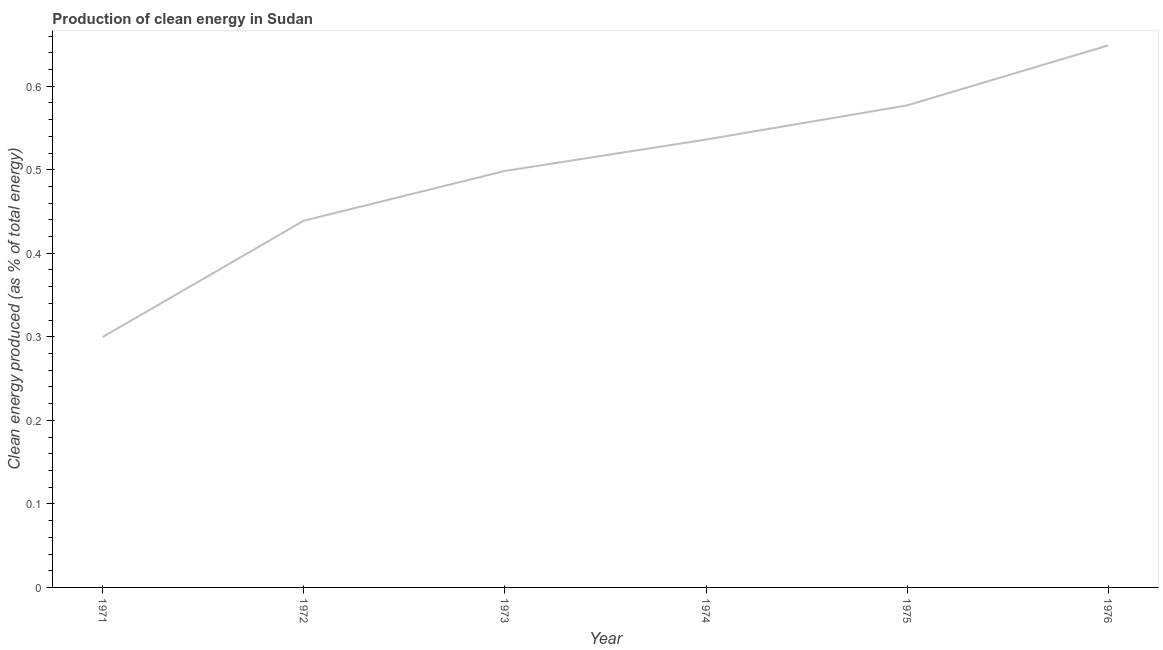What is the production of clean energy in 1971?
Ensure brevity in your answer.  0.3. Across all years, what is the maximum production of clean energy?
Your answer should be compact. 0.65. Across all years, what is the minimum production of clean energy?
Ensure brevity in your answer.  0.3. In which year was the production of clean energy maximum?
Provide a short and direct response. 1976. In which year was the production of clean energy minimum?
Keep it short and to the point. 1971. What is the sum of the production of clean energy?
Make the answer very short. 3. What is the difference between the production of clean energy in 1971 and 1976?
Make the answer very short. -0.35. What is the average production of clean energy per year?
Give a very brief answer. 0.5. What is the median production of clean energy?
Offer a very short reply. 0.52. What is the ratio of the production of clean energy in 1971 to that in 1974?
Give a very brief answer. 0.56. What is the difference between the highest and the second highest production of clean energy?
Provide a succinct answer. 0.07. What is the difference between the highest and the lowest production of clean energy?
Give a very brief answer. 0.35. In how many years, is the production of clean energy greater than the average production of clean energy taken over all years?
Provide a short and direct response. 3. How many lines are there?
Your response must be concise. 1. What is the difference between two consecutive major ticks on the Y-axis?
Offer a very short reply. 0.1. What is the title of the graph?
Provide a succinct answer. Production of clean energy in Sudan. What is the label or title of the X-axis?
Your answer should be very brief. Year. What is the label or title of the Y-axis?
Your answer should be very brief. Clean energy produced (as % of total energy). What is the Clean energy produced (as % of total energy) of 1971?
Your answer should be very brief. 0.3. What is the Clean energy produced (as % of total energy) in 1972?
Ensure brevity in your answer.  0.44. What is the Clean energy produced (as % of total energy) of 1973?
Provide a succinct answer. 0.5. What is the Clean energy produced (as % of total energy) of 1974?
Your answer should be compact. 0.54. What is the Clean energy produced (as % of total energy) in 1975?
Provide a short and direct response. 0.58. What is the Clean energy produced (as % of total energy) in 1976?
Offer a terse response. 0.65. What is the difference between the Clean energy produced (as % of total energy) in 1971 and 1972?
Provide a succinct answer. -0.14. What is the difference between the Clean energy produced (as % of total energy) in 1971 and 1973?
Give a very brief answer. -0.2. What is the difference between the Clean energy produced (as % of total energy) in 1971 and 1974?
Give a very brief answer. -0.24. What is the difference between the Clean energy produced (as % of total energy) in 1971 and 1975?
Give a very brief answer. -0.28. What is the difference between the Clean energy produced (as % of total energy) in 1971 and 1976?
Give a very brief answer. -0.35. What is the difference between the Clean energy produced (as % of total energy) in 1972 and 1973?
Offer a very short reply. -0.06. What is the difference between the Clean energy produced (as % of total energy) in 1972 and 1974?
Keep it short and to the point. -0.1. What is the difference between the Clean energy produced (as % of total energy) in 1972 and 1975?
Your answer should be very brief. -0.14. What is the difference between the Clean energy produced (as % of total energy) in 1972 and 1976?
Ensure brevity in your answer.  -0.21. What is the difference between the Clean energy produced (as % of total energy) in 1973 and 1974?
Provide a succinct answer. -0.04. What is the difference between the Clean energy produced (as % of total energy) in 1973 and 1975?
Provide a short and direct response. -0.08. What is the difference between the Clean energy produced (as % of total energy) in 1973 and 1976?
Keep it short and to the point. -0.15. What is the difference between the Clean energy produced (as % of total energy) in 1974 and 1975?
Your response must be concise. -0.04. What is the difference between the Clean energy produced (as % of total energy) in 1974 and 1976?
Give a very brief answer. -0.11. What is the difference between the Clean energy produced (as % of total energy) in 1975 and 1976?
Give a very brief answer. -0.07. What is the ratio of the Clean energy produced (as % of total energy) in 1971 to that in 1972?
Provide a succinct answer. 0.68. What is the ratio of the Clean energy produced (as % of total energy) in 1971 to that in 1973?
Provide a succinct answer. 0.6. What is the ratio of the Clean energy produced (as % of total energy) in 1971 to that in 1974?
Your answer should be very brief. 0.56. What is the ratio of the Clean energy produced (as % of total energy) in 1971 to that in 1975?
Make the answer very short. 0.52. What is the ratio of the Clean energy produced (as % of total energy) in 1971 to that in 1976?
Give a very brief answer. 0.46. What is the ratio of the Clean energy produced (as % of total energy) in 1972 to that in 1973?
Keep it short and to the point. 0.88. What is the ratio of the Clean energy produced (as % of total energy) in 1972 to that in 1974?
Your response must be concise. 0.82. What is the ratio of the Clean energy produced (as % of total energy) in 1972 to that in 1975?
Your answer should be very brief. 0.76. What is the ratio of the Clean energy produced (as % of total energy) in 1972 to that in 1976?
Offer a very short reply. 0.68. What is the ratio of the Clean energy produced (as % of total energy) in 1973 to that in 1975?
Provide a short and direct response. 0.86. What is the ratio of the Clean energy produced (as % of total energy) in 1973 to that in 1976?
Ensure brevity in your answer.  0.77. What is the ratio of the Clean energy produced (as % of total energy) in 1974 to that in 1975?
Give a very brief answer. 0.93. What is the ratio of the Clean energy produced (as % of total energy) in 1974 to that in 1976?
Your response must be concise. 0.83. What is the ratio of the Clean energy produced (as % of total energy) in 1975 to that in 1976?
Offer a very short reply. 0.89. 